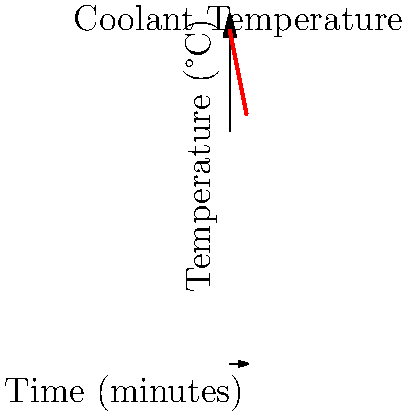The graph shows the temperature of engine coolant over time as it flows through a radiator. If the coolant's specific heat capacity is 3.85 J/(g·°C) and its flow rate is 2 kg/min, what is the average rate of heat transfer from the coolant to the surroundings during the 5-minute period? To solve this problem, we'll follow these steps:

1. Calculate the temperature change:
   Initial temperature = 100°C
   Final temperature = 75°C
   $\Delta T = 100°C - 75°C = 25°C$

2. Calculate the mass of coolant over 5 minutes:
   Flow rate = 2 kg/min
   Time = 5 min
   Mass = 2 kg/min × 5 min = 10 kg

3. Calculate the heat transferred:
   $Q = mc\Delta T$
   where:
   $m$ = mass of coolant (10 kg)
   $c$ = specific heat capacity (3.85 kJ/(kg·°C))
   $\Delta T$ = temperature change (25°C)

   $Q = 10 \text{ kg} \times 3.85 \text{ kJ/(kg·°C)} \times 25°C = 962.5 \text{ kJ}$

4. Calculate the average rate of heat transfer:
   Rate = Heat transferred / Time
   $\text{Rate} = 962.5 \text{ kJ} / 5 \text{ min} = 192.5 \text{ kJ/min}$

5. Convert to watts:
   $192.5 \text{ kJ/min} \times (1 \text{ min} / 60 \text{ s}) = 3.21 \text{ kW}$
Answer: 3.21 kW 